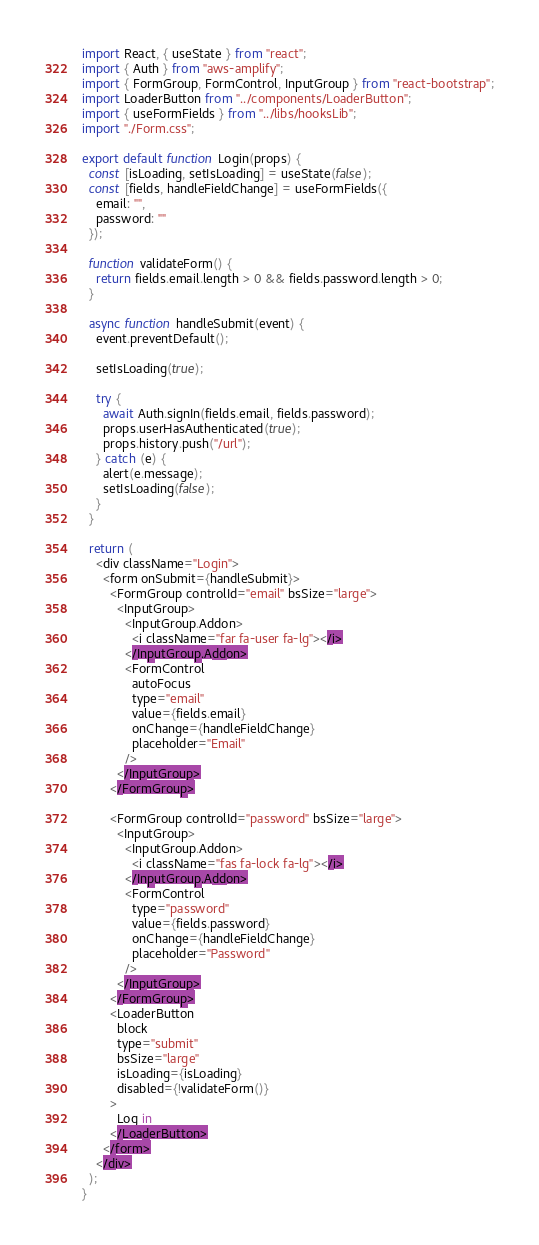Convert code to text. <code><loc_0><loc_0><loc_500><loc_500><_JavaScript_>import React, { useState } from "react";
import { Auth } from "aws-amplify";
import { FormGroup, FormControl, InputGroup } from "react-bootstrap";
import LoaderButton from "../components/LoaderButton";
import { useFormFields } from "../libs/hooksLib";
import "./Form.css";

export default function Login(props) {
  const [isLoading, setIsLoading] = useState(false);
  const [fields, handleFieldChange] = useFormFields({
    email: "",
    password: ""
  });

  function validateForm() {
    return fields.email.length > 0 && fields.password.length > 0;
  }

  async function handleSubmit(event) {
    event.preventDefault();

    setIsLoading(true);

    try {
      await Auth.signIn(fields.email, fields.password);
      props.userHasAuthenticated(true);
      props.history.push("/url");
    } catch (e) {
      alert(e.message);
      setIsLoading(false);
    }
  }

  return (
    <div className="Login">
      <form onSubmit={handleSubmit}>
        <FormGroup controlId="email" bsSize="large">
          <InputGroup>
            <InputGroup.Addon>
              <i className="far fa-user fa-lg"></i>
            </InputGroup.Addon>
            <FormControl
              autoFocus
              type="email"
              value={fields.email}
              onChange={handleFieldChange}
              placeholder="Email"
            />                
          </InputGroup>
        </FormGroup>

        <FormGroup controlId="password" bsSize="large">
          <InputGroup>
            <InputGroup.Addon>
              <i className="fas fa-lock fa-lg"></i>
            </InputGroup.Addon>
            <FormControl
              type="password"
              value={fields.password}
              onChange={handleFieldChange}
              placeholder="Password"
            />
          </InputGroup>
        </FormGroup>
        <LoaderButton
          block
          type="submit"
          bsSize="large"
          isLoading={isLoading}
          disabled={!validateForm()}
        >
          Log in
        </LoaderButton>
      </form>
    </div>
  );
}
</code> 